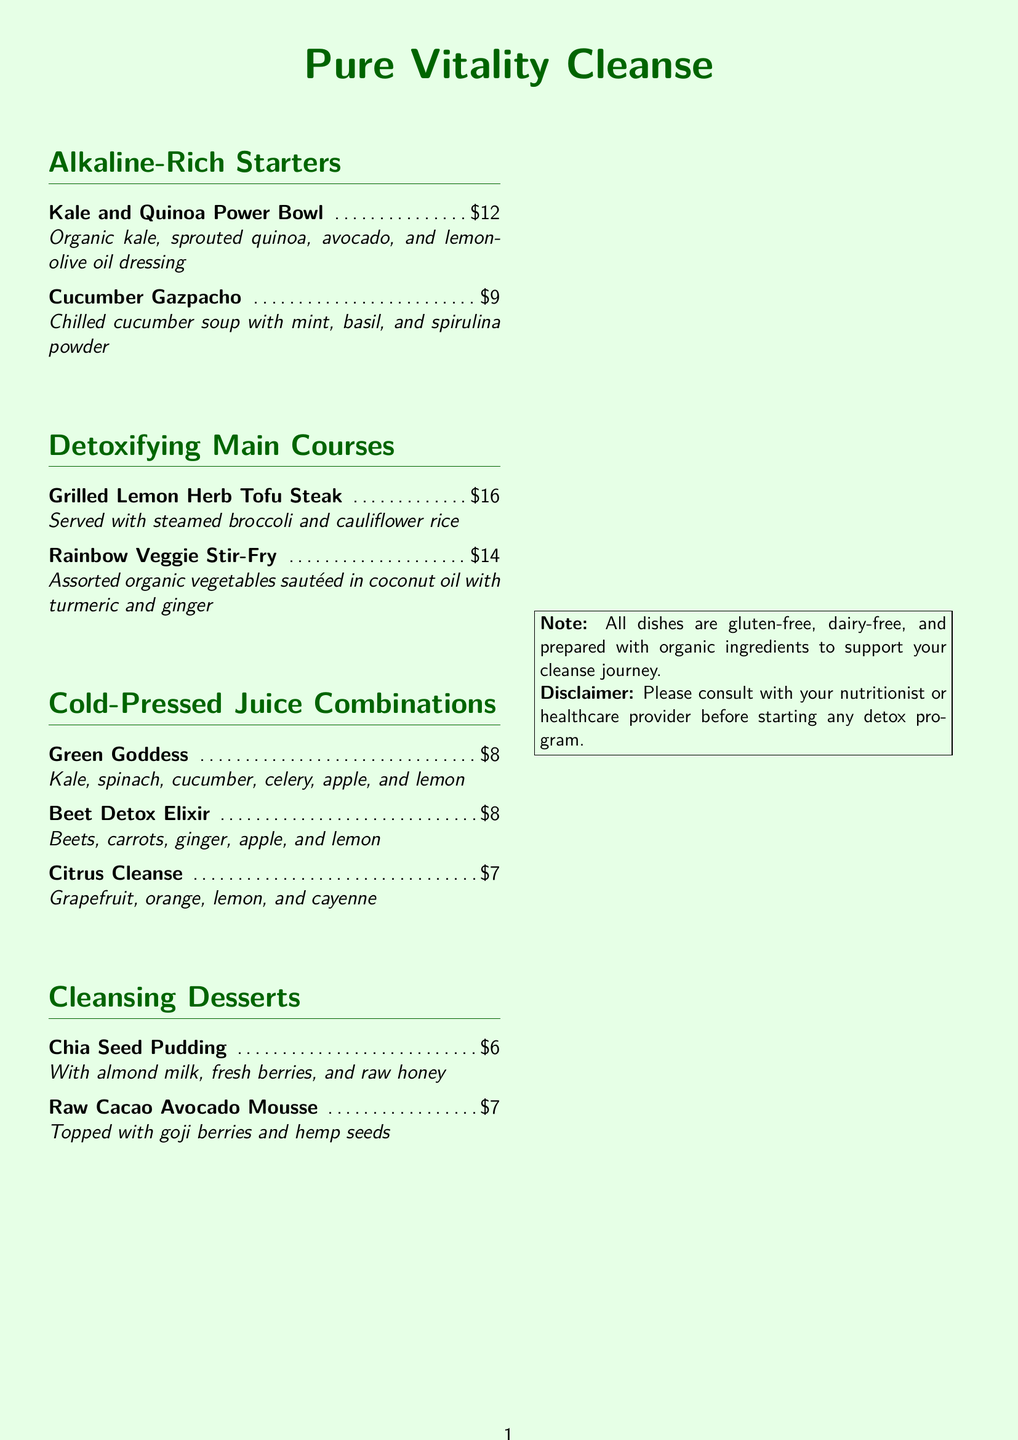What is the price of the Kale and Quinoa Power Bowl? The price is clearly listed next to the dish name in the menu.
Answer: $12 What ingredients are in the Green Goddess juice? The juice ingredients are listed in the description under Cold-Pressed Juice Combinations.
Answer: Kale, spinach, cucumber, celery, apple, and lemon How many cleansing desserts are offered? The number of desserts can be counted from the Cleansing Desserts section of the menu.
Answer: 2 What cooking oil is used for the Rainbow Veggie Stir-Fry? The cooking oil used is mentioned in the description of the dish on the menu.
Answer: Coconut oil Which dish is served with steamed broccoli? The dish served with steamed broccoli is identified by its description in the Detoxifying Main Courses.
Answer: Grilled Lemon Herb Tofu Steak What is the main sweetener used in the Chia Seed Pudding? The sweetener used is specified in the description of the dessert on the menu.
Answer: Raw honey Which juice contains cayenne? The juice containing cayenne is specified in its description under Cold-Pressed Juice Combinations.
Answer: Citrus Cleanse Are all dishes gluten-free? This information is mentioned in the note at the bottom of the menu.
Answer: Yes 